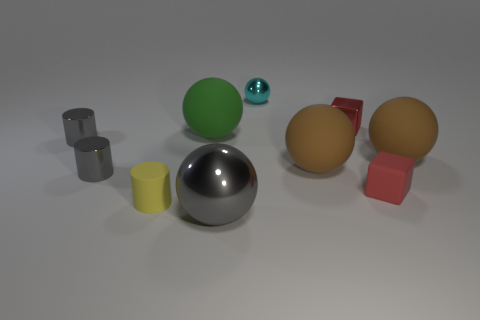Does the tiny rubber object to the right of the big green matte sphere have the same color as the metal cube?
Provide a succinct answer. Yes. Do the metal block and the cube in front of the big green ball have the same color?
Provide a succinct answer. Yes. Do the rubber block and the metallic block have the same color?
Your response must be concise. Yes. What material is the brown thing that is on the left side of the metallic thing that is on the right side of the cyan sphere?
Ensure brevity in your answer.  Rubber. Are there any blue cylinders made of the same material as the green object?
Give a very brief answer. No. There is a brown matte object to the left of the tiny rubber object on the right side of the metal sphere behind the tiny red shiny block; what is its shape?
Keep it short and to the point. Sphere. What material is the gray ball?
Give a very brief answer. Metal. What color is the other sphere that is the same material as the cyan ball?
Provide a short and direct response. Gray. Is there a gray metallic object that is in front of the sphere right of the small shiny cube?
Your answer should be very brief. Yes. How many other things are there of the same shape as the large gray metal thing?
Keep it short and to the point. 4. 